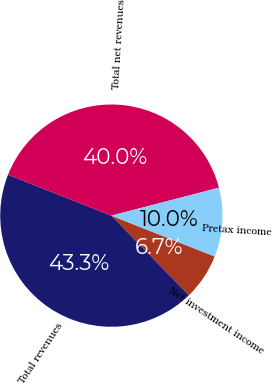Convert chart. <chart><loc_0><loc_0><loc_500><loc_500><pie_chart><fcel>Net investment income<fcel>Total revenues<fcel>Total net revenues<fcel>Pretax income<nl><fcel>6.72%<fcel>43.28%<fcel>39.96%<fcel>10.04%<nl></chart> 